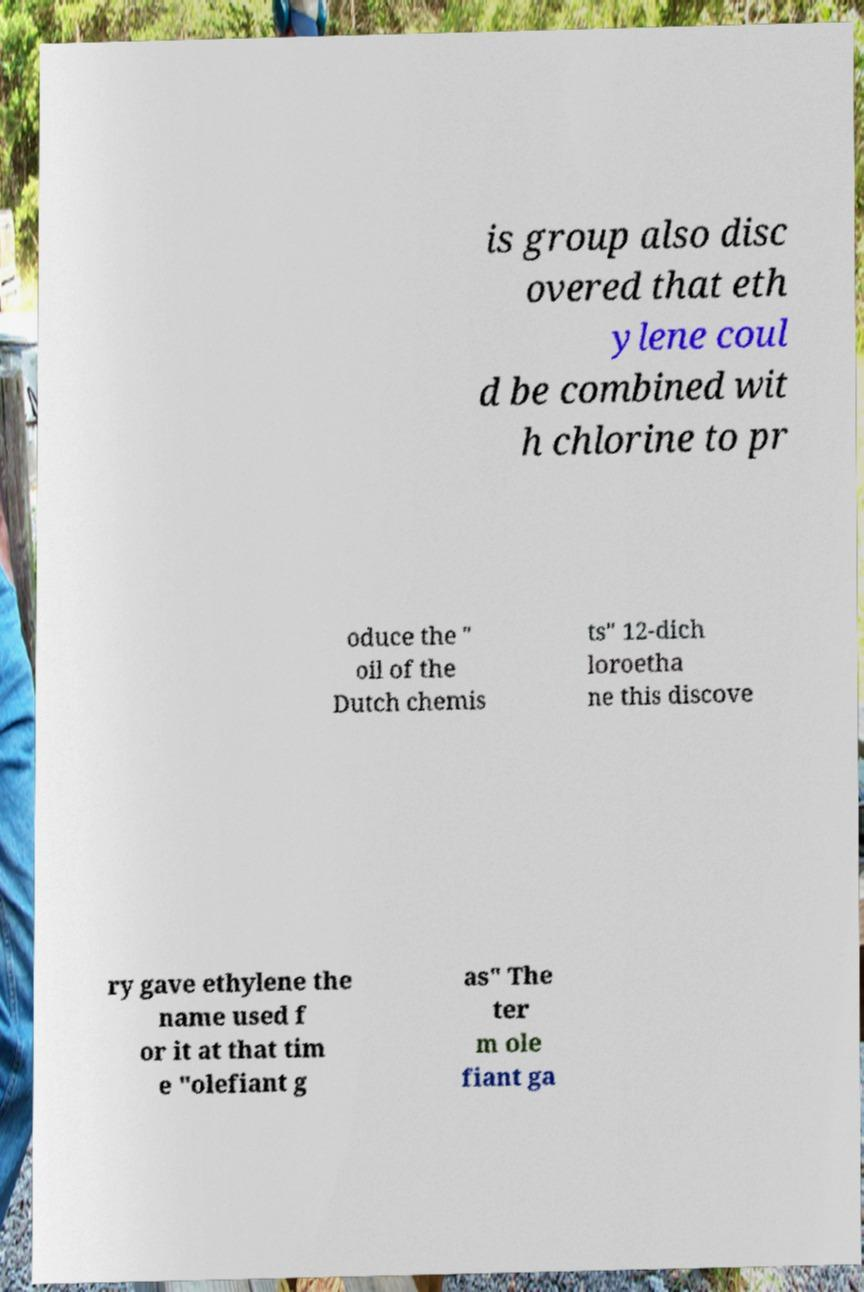Please identify and transcribe the text found in this image. is group also disc overed that eth ylene coul d be combined wit h chlorine to pr oduce the " oil of the Dutch chemis ts" 12-dich loroetha ne this discove ry gave ethylene the name used f or it at that tim e "olefiant g as" The ter m ole fiant ga 